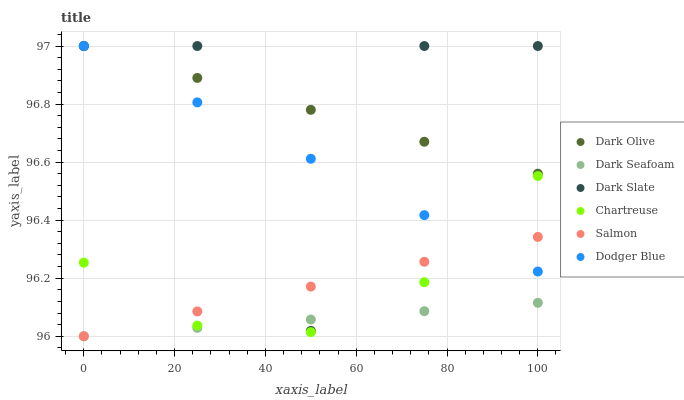Does Dark Seafoam have the minimum area under the curve?
Answer yes or no. Yes. Does Dark Olive have the maximum area under the curve?
Answer yes or no. Yes. Does Salmon have the minimum area under the curve?
Answer yes or no. No. Does Salmon have the maximum area under the curve?
Answer yes or no. No. Is Dark Seafoam the smoothest?
Answer yes or no. Yes. Is Dark Slate the roughest?
Answer yes or no. Yes. Is Salmon the smoothest?
Answer yes or no. No. Is Salmon the roughest?
Answer yes or no. No. Does Salmon have the lowest value?
Answer yes or no. Yes. Does Chartreuse have the lowest value?
Answer yes or no. No. Does Dodger Blue have the highest value?
Answer yes or no. Yes. Does Salmon have the highest value?
Answer yes or no. No. Is Dark Seafoam less than Dodger Blue?
Answer yes or no. Yes. Is Dark Olive greater than Dark Seafoam?
Answer yes or no. Yes. Does Dodger Blue intersect Dark Olive?
Answer yes or no. Yes. Is Dodger Blue less than Dark Olive?
Answer yes or no. No. Is Dodger Blue greater than Dark Olive?
Answer yes or no. No. Does Dark Seafoam intersect Dodger Blue?
Answer yes or no. No. 